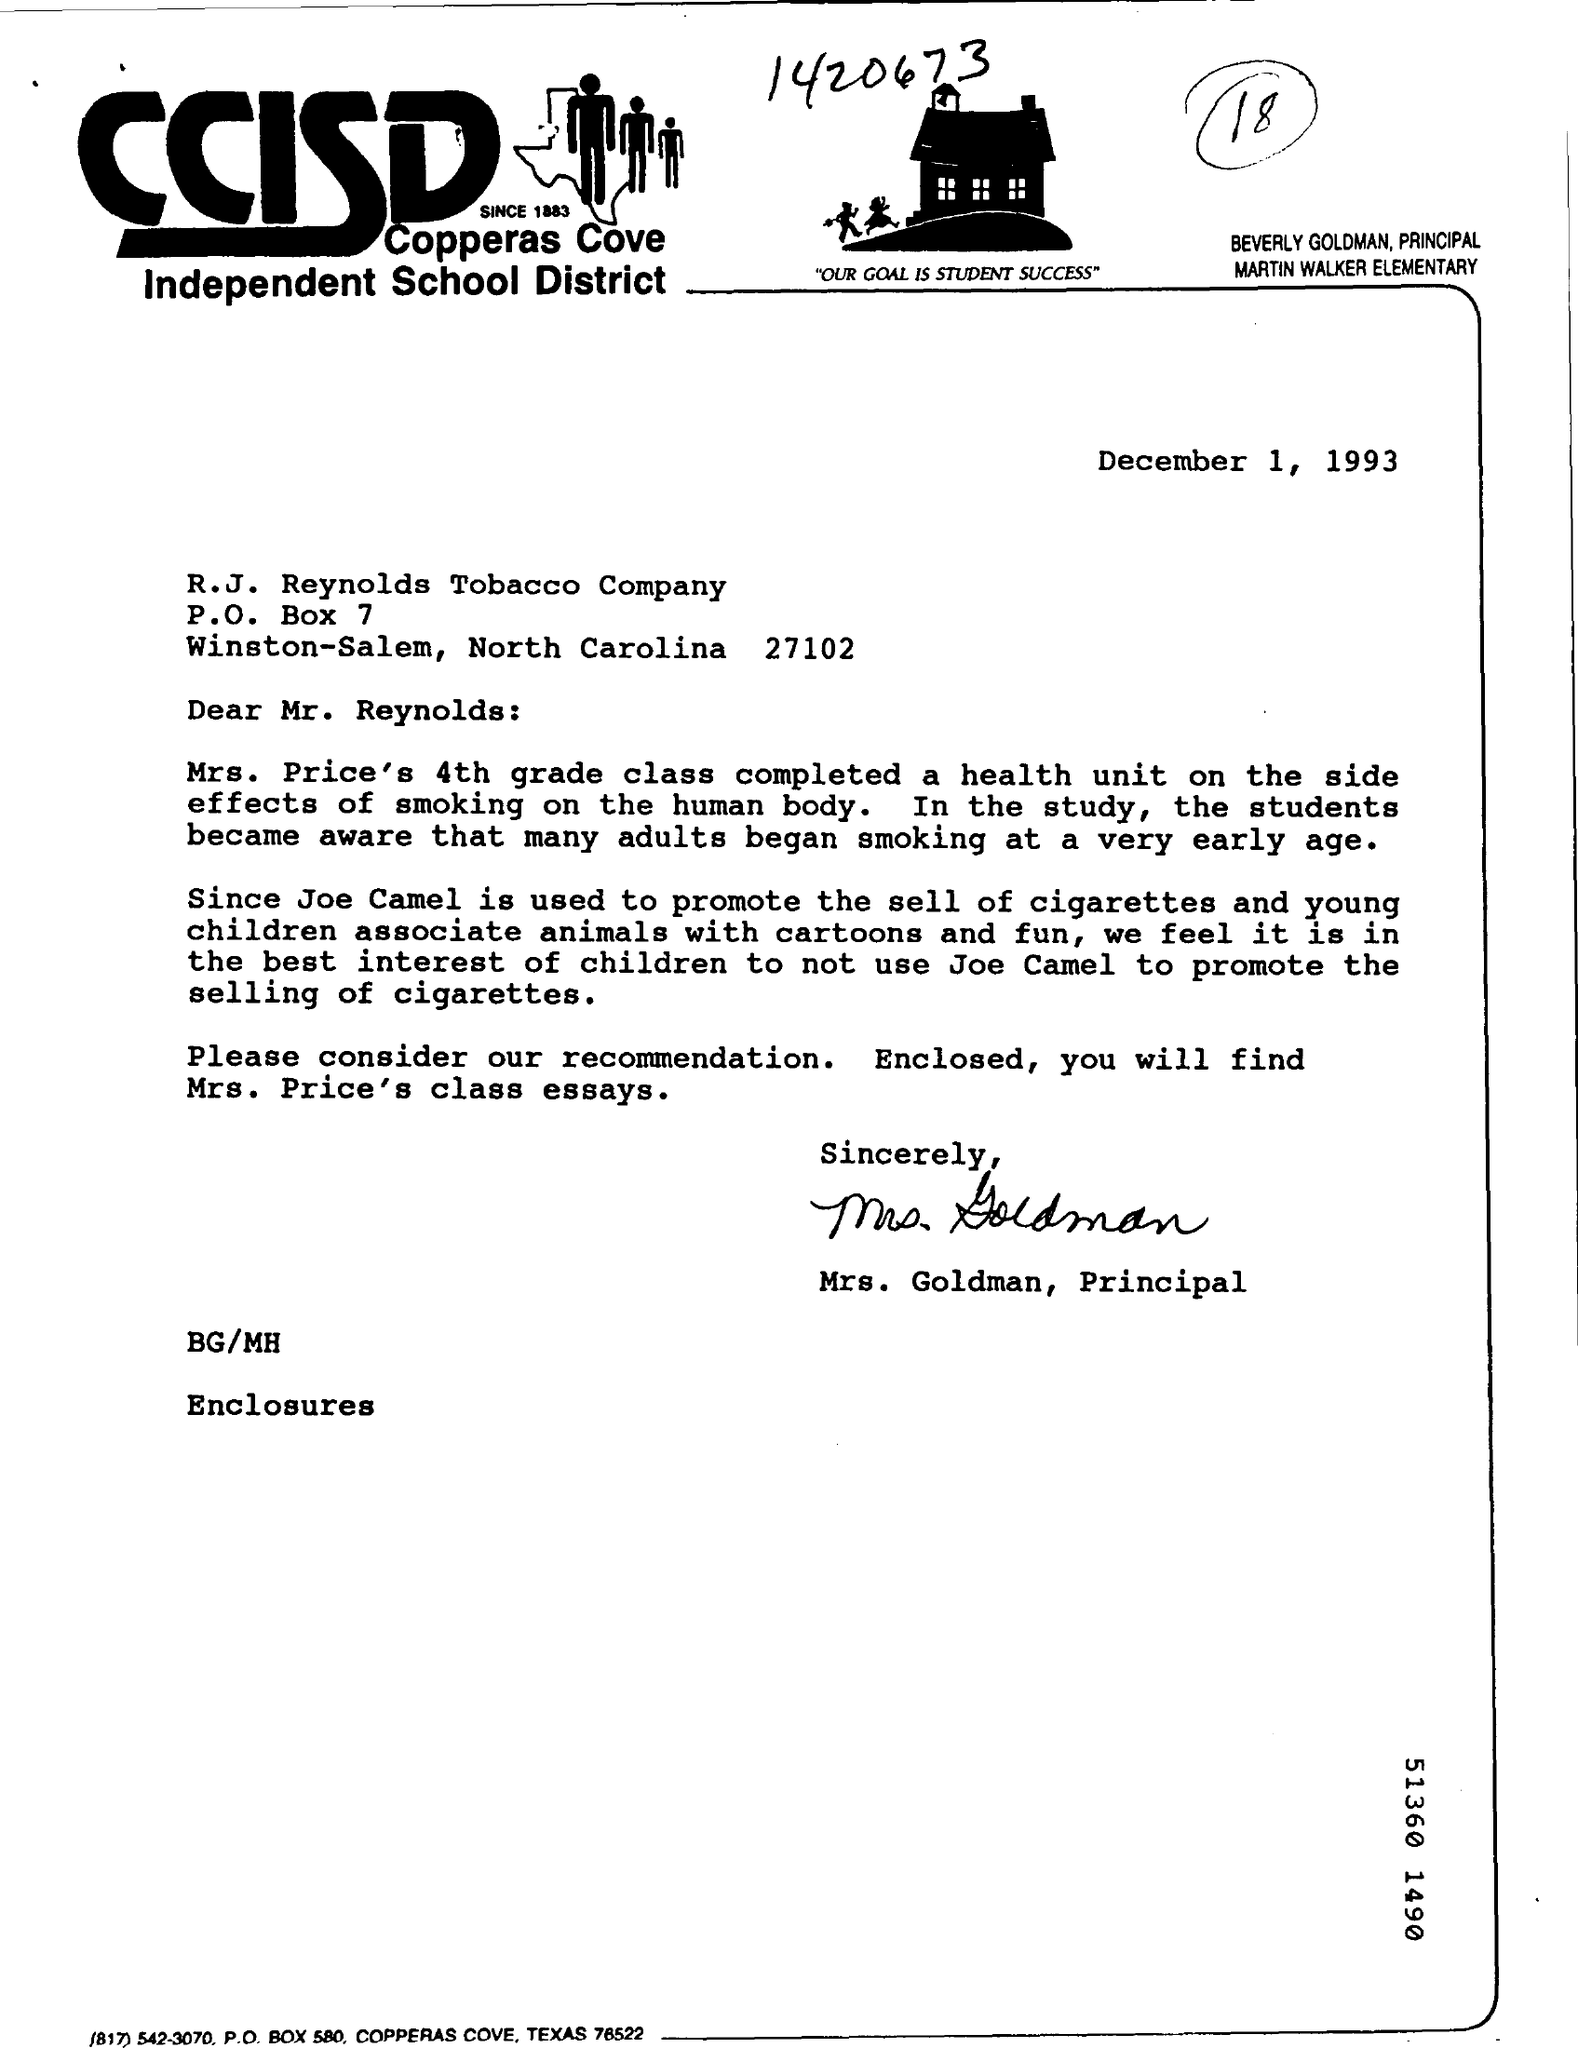Outline some significant characteristics in this image. Copperas Cove Independent School District (CCISD) is a public school district located in Copperas Cove, Texas, United States. It serves the cities of Copperas Cove and Bagdad, as well as the surrounding areas. CCISD is committed to providing a high-quality education to its students and promoting academic excellence. There is a number at the top of the document that has been rounded up to 18. The date mentioned at the top of the document is December 1, 1993. What is the P.O Box Number? It is 7. 